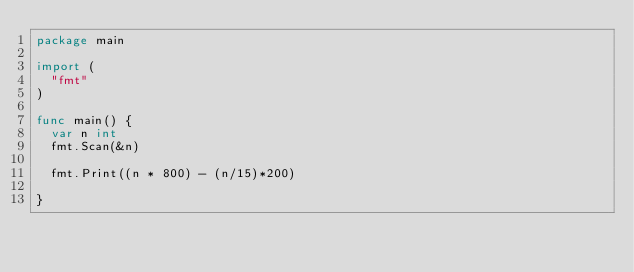Convert code to text. <code><loc_0><loc_0><loc_500><loc_500><_Go_>package main

import (
	"fmt"
)

func main() {
	var n int
	fmt.Scan(&n)

	fmt.Print((n * 800) - (n/15)*200)

}
</code> 